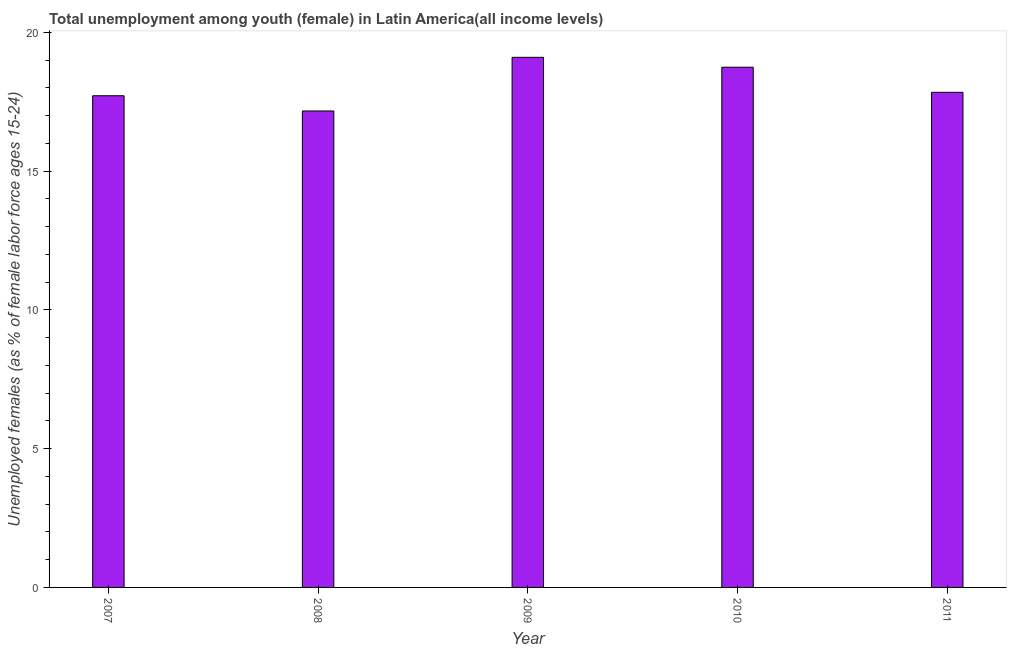Does the graph contain grids?
Ensure brevity in your answer.  No. What is the title of the graph?
Give a very brief answer. Total unemployment among youth (female) in Latin America(all income levels). What is the label or title of the X-axis?
Make the answer very short. Year. What is the label or title of the Y-axis?
Your response must be concise. Unemployed females (as % of female labor force ages 15-24). What is the unemployed female youth population in 2008?
Offer a very short reply. 17.16. Across all years, what is the maximum unemployed female youth population?
Keep it short and to the point. 19.1. Across all years, what is the minimum unemployed female youth population?
Provide a short and direct response. 17.16. In which year was the unemployed female youth population maximum?
Offer a terse response. 2009. What is the sum of the unemployed female youth population?
Provide a succinct answer. 90.55. What is the difference between the unemployed female youth population in 2009 and 2011?
Offer a terse response. 1.26. What is the average unemployed female youth population per year?
Your answer should be compact. 18.11. What is the median unemployed female youth population?
Provide a succinct answer. 17.84. In how many years, is the unemployed female youth population greater than 17 %?
Provide a short and direct response. 5. Is the unemployed female youth population in 2007 less than that in 2008?
Your answer should be compact. No. Is the difference between the unemployed female youth population in 2010 and 2011 greater than the difference between any two years?
Offer a very short reply. No. What is the difference between the highest and the second highest unemployed female youth population?
Your response must be concise. 0.36. What is the difference between the highest and the lowest unemployed female youth population?
Give a very brief answer. 1.93. In how many years, is the unemployed female youth population greater than the average unemployed female youth population taken over all years?
Your response must be concise. 2. Are all the bars in the graph horizontal?
Your response must be concise. No. How many years are there in the graph?
Provide a short and direct response. 5. What is the difference between two consecutive major ticks on the Y-axis?
Make the answer very short. 5. Are the values on the major ticks of Y-axis written in scientific E-notation?
Provide a short and direct response. No. What is the Unemployed females (as % of female labor force ages 15-24) of 2007?
Make the answer very short. 17.71. What is the Unemployed females (as % of female labor force ages 15-24) of 2008?
Give a very brief answer. 17.16. What is the Unemployed females (as % of female labor force ages 15-24) in 2009?
Give a very brief answer. 19.1. What is the Unemployed females (as % of female labor force ages 15-24) in 2010?
Provide a succinct answer. 18.74. What is the Unemployed females (as % of female labor force ages 15-24) in 2011?
Provide a succinct answer. 17.84. What is the difference between the Unemployed females (as % of female labor force ages 15-24) in 2007 and 2008?
Provide a short and direct response. 0.55. What is the difference between the Unemployed females (as % of female labor force ages 15-24) in 2007 and 2009?
Your answer should be compact. -1.38. What is the difference between the Unemployed females (as % of female labor force ages 15-24) in 2007 and 2010?
Your answer should be compact. -1.03. What is the difference between the Unemployed females (as % of female labor force ages 15-24) in 2007 and 2011?
Give a very brief answer. -0.12. What is the difference between the Unemployed females (as % of female labor force ages 15-24) in 2008 and 2009?
Make the answer very short. -1.93. What is the difference between the Unemployed females (as % of female labor force ages 15-24) in 2008 and 2010?
Your response must be concise. -1.58. What is the difference between the Unemployed females (as % of female labor force ages 15-24) in 2008 and 2011?
Make the answer very short. -0.67. What is the difference between the Unemployed females (as % of female labor force ages 15-24) in 2009 and 2010?
Your answer should be very brief. 0.36. What is the difference between the Unemployed females (as % of female labor force ages 15-24) in 2009 and 2011?
Make the answer very short. 1.26. What is the difference between the Unemployed females (as % of female labor force ages 15-24) in 2010 and 2011?
Provide a succinct answer. 0.9. What is the ratio of the Unemployed females (as % of female labor force ages 15-24) in 2007 to that in 2008?
Provide a succinct answer. 1.03. What is the ratio of the Unemployed females (as % of female labor force ages 15-24) in 2007 to that in 2009?
Keep it short and to the point. 0.93. What is the ratio of the Unemployed females (as % of female labor force ages 15-24) in 2007 to that in 2010?
Provide a succinct answer. 0.94. What is the ratio of the Unemployed females (as % of female labor force ages 15-24) in 2007 to that in 2011?
Keep it short and to the point. 0.99. What is the ratio of the Unemployed females (as % of female labor force ages 15-24) in 2008 to that in 2009?
Provide a succinct answer. 0.9. What is the ratio of the Unemployed females (as % of female labor force ages 15-24) in 2008 to that in 2010?
Make the answer very short. 0.92. What is the ratio of the Unemployed females (as % of female labor force ages 15-24) in 2008 to that in 2011?
Your response must be concise. 0.96. What is the ratio of the Unemployed females (as % of female labor force ages 15-24) in 2009 to that in 2010?
Your answer should be very brief. 1.02. What is the ratio of the Unemployed females (as % of female labor force ages 15-24) in 2009 to that in 2011?
Ensure brevity in your answer.  1.07. What is the ratio of the Unemployed females (as % of female labor force ages 15-24) in 2010 to that in 2011?
Offer a terse response. 1.05. 